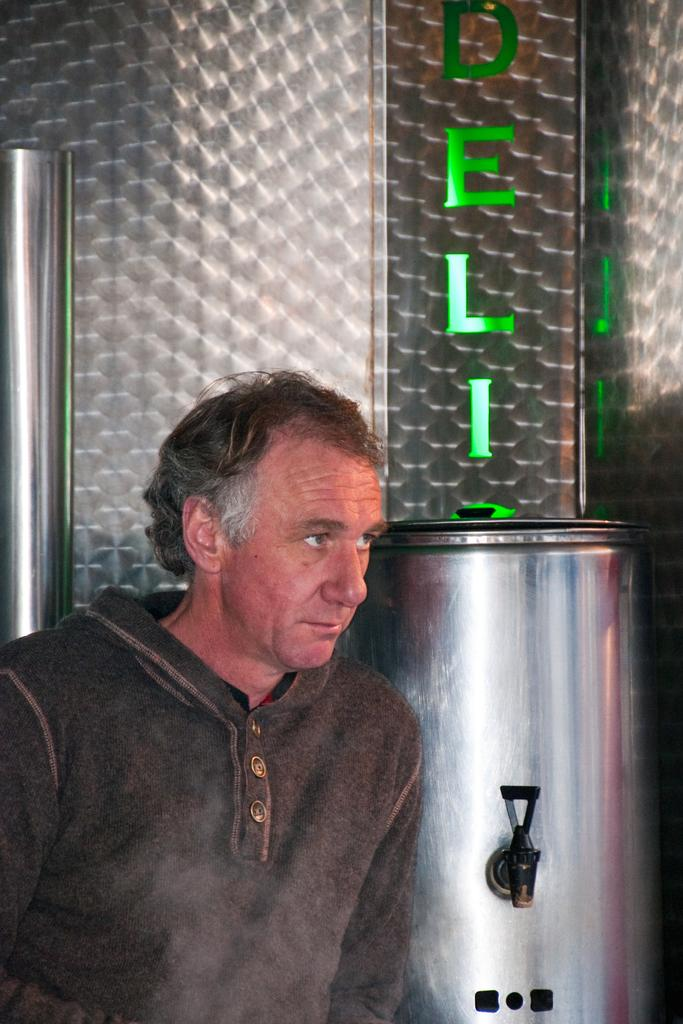<image>
Provide a brief description of the given image. A man next to a tea urn that shows ELI over it. 